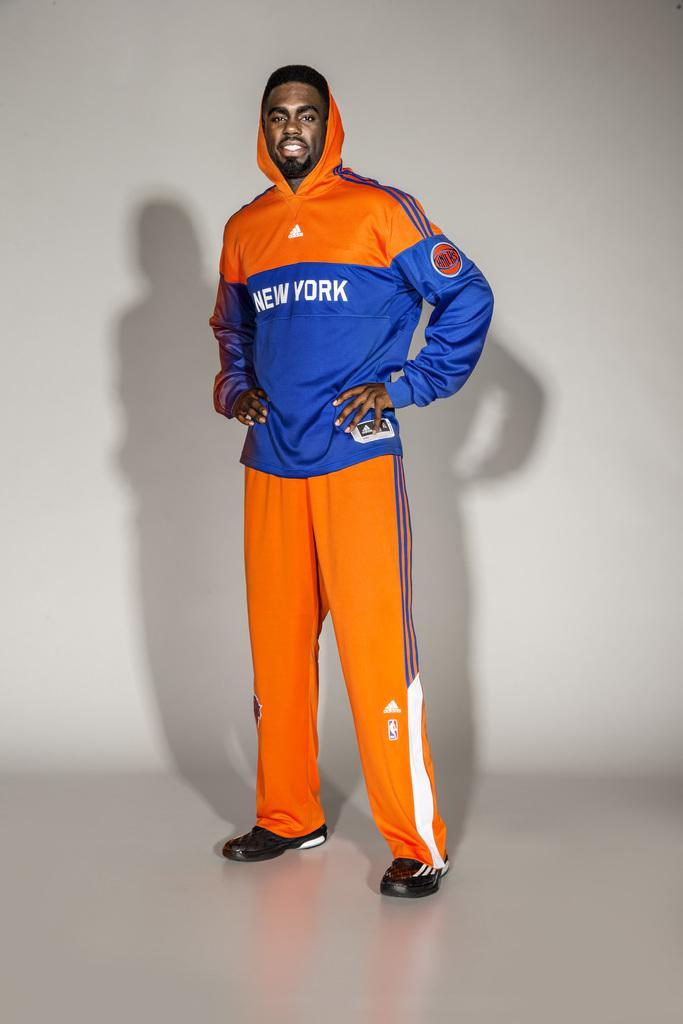<image>
Provide a brief description of the given image. An African American male standing in a orange and blue New york sweat suit. 